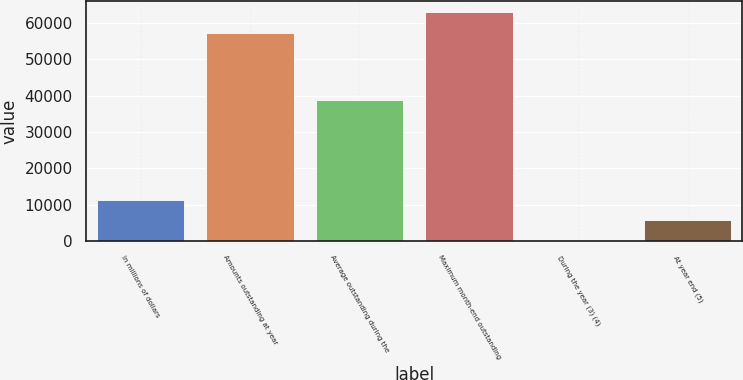<chart> <loc_0><loc_0><loc_500><loc_500><bar_chart><fcel>In millions of dollars<fcel>Amounts outstanding at year<fcel>Average outstanding during the<fcel>Maximum month-end outstanding<fcel>During the year (3) (4)<fcel>At year end (5)<nl><fcel>11430.6<fcel>57138<fcel>38691<fcel>62851.4<fcel>3.71<fcel>5717.14<nl></chart> 